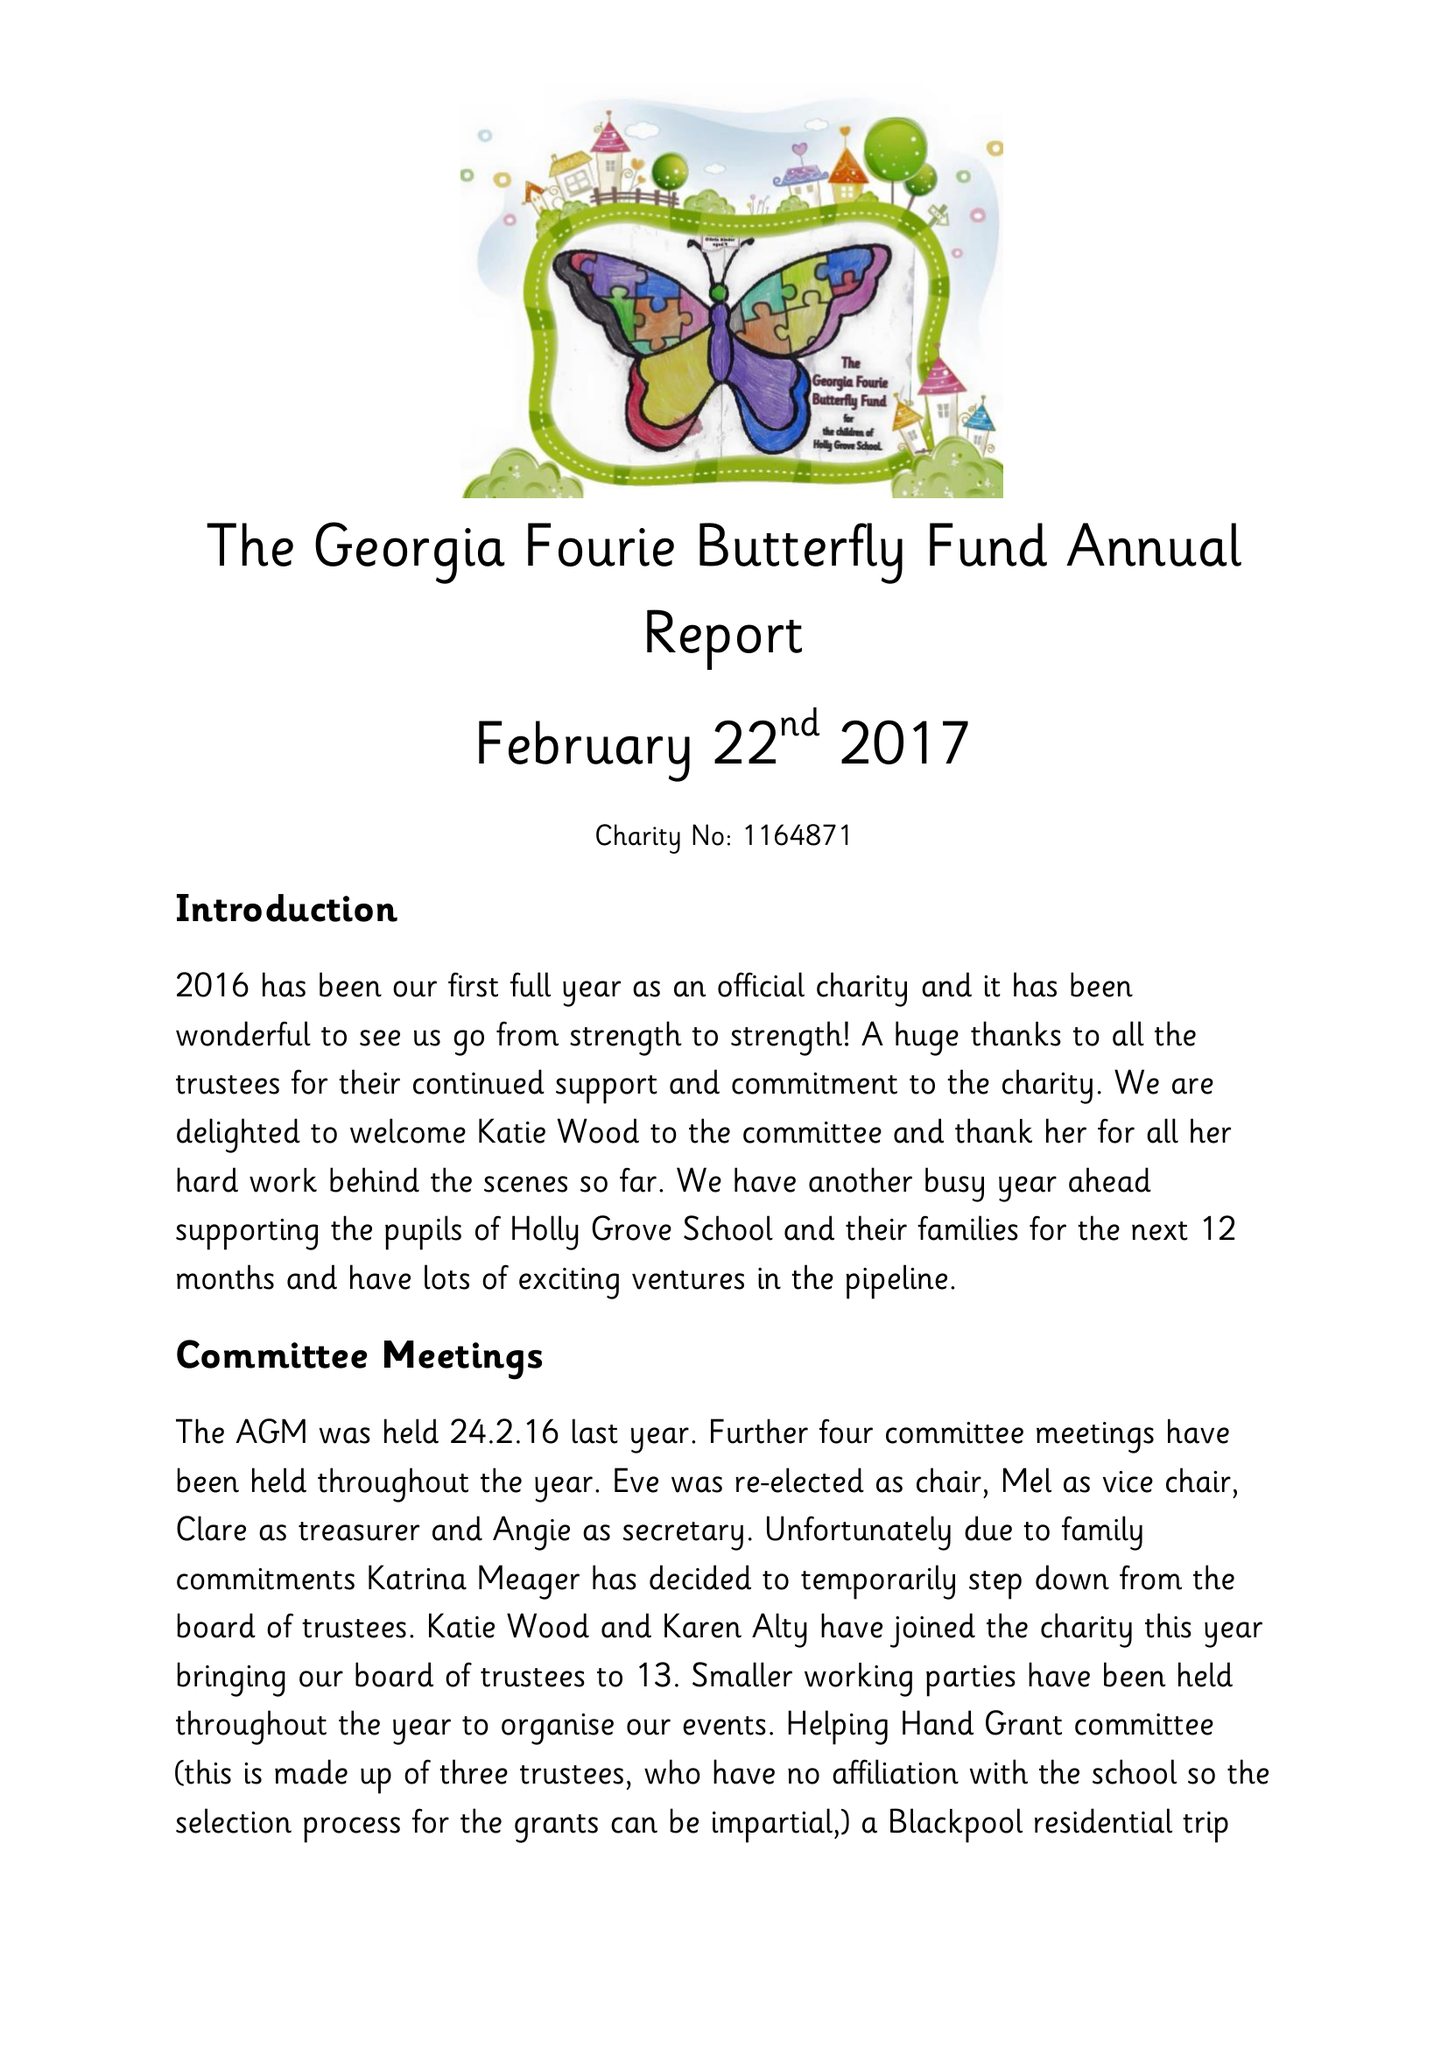What is the value for the report_date?
Answer the question using a single word or phrase. 2016-08-31 